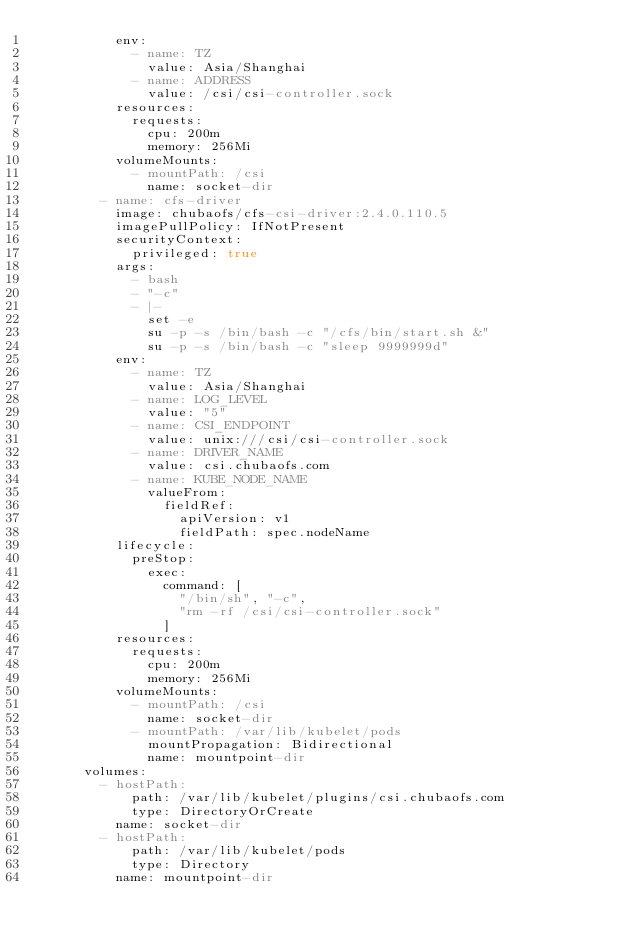<code> <loc_0><loc_0><loc_500><loc_500><_YAML_>          env:
            - name: TZ
              value: Asia/Shanghai
            - name: ADDRESS
              value: /csi/csi-controller.sock
          resources:
            requests:
              cpu: 200m
              memory: 256Mi
          volumeMounts:
            - mountPath: /csi
              name: socket-dir
        - name: cfs-driver
          image: chubaofs/cfs-csi-driver:2.4.0.110.5
          imagePullPolicy: IfNotPresent
          securityContext:
            privileged: true
          args:
            - bash
            - "-c"
            - |-
              set -e
              su -p -s /bin/bash -c "/cfs/bin/start.sh &"
              su -p -s /bin/bash -c "sleep 9999999d"
          env:
            - name: TZ
              value: Asia/Shanghai
            - name: LOG_LEVEL
              value: "5"
            - name: CSI_ENDPOINT
              value: unix:///csi/csi-controller.sock
            - name: DRIVER_NAME
              value: csi.chubaofs.com
            - name: KUBE_NODE_NAME
              valueFrom:
                fieldRef:
                  apiVersion: v1
                  fieldPath: spec.nodeName
          lifecycle:
            preStop:
              exec:
                command: [
                  "/bin/sh", "-c",
                  "rm -rf /csi/csi-controller.sock"
                ]
          resources:
            requests:
              cpu: 200m
              memory: 256Mi
          volumeMounts:
            - mountPath: /csi
              name: socket-dir
            - mountPath: /var/lib/kubelet/pods
              mountPropagation: Bidirectional
              name: mountpoint-dir
      volumes:
        - hostPath:
            path: /var/lib/kubelet/plugins/csi.chubaofs.com
            type: DirectoryOrCreate
          name: socket-dir
        - hostPath:
            path: /var/lib/kubelet/pods
            type: Directory
          name: mountpoint-dir
</code> 